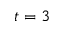<formula> <loc_0><loc_0><loc_500><loc_500>t = 3</formula> 